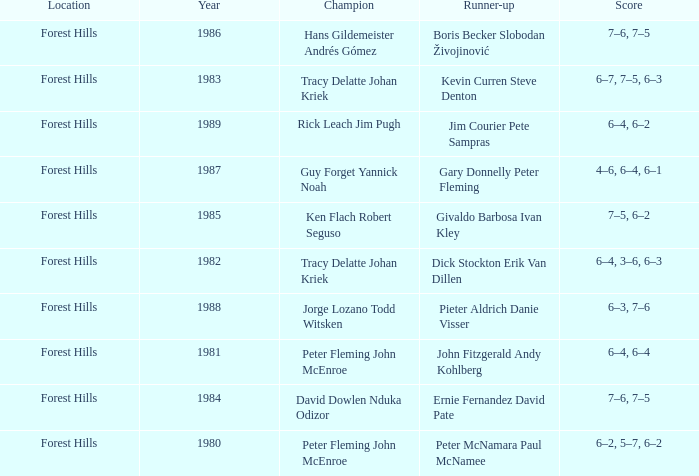Who was the runner-up in 1989? Jim Courier Pete Sampras. 